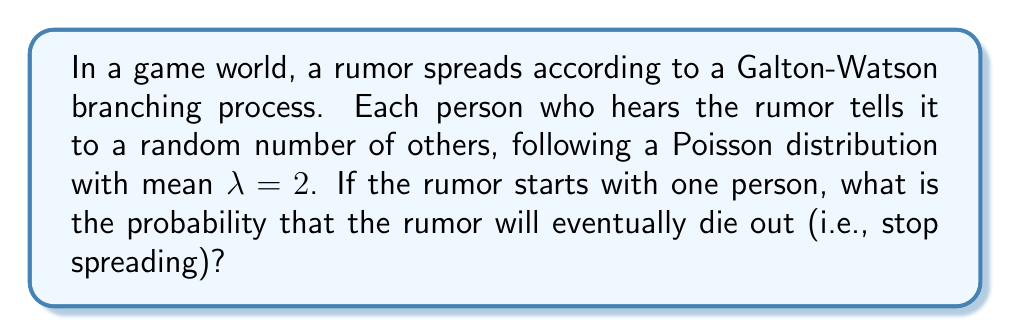Help me with this question. To solve this problem, we'll follow these steps:

1) In a Galton-Watson process, the probability of extinction is the smallest non-negative root of the equation:

   $$s = G(s)$$

   where $G(s)$ is the probability generating function of the offspring distribution.

2) For a Poisson distribution with mean $\lambda$, the probability generating function is:

   $$G(s) = e^{\lambda(s-1)}$$

3) Substituting our $\lambda = 2$, we get:

   $$s = e^{2(s-1)}$$

4) This equation cannot be solved algebraically. We need to use numerical methods.

5) We can see that $s = 1$ is always a solution, but this is not always the smallest positive root.

6) For a branching process, the extinction probability is less than 1 if and only if $\lambda > 1$.

7) Since our $\lambda = 2 > 1$, we know the extinction probability is less than 1.

8) Using numerical methods (e.g., Newton's method), we can find that the smallest positive root is approximately 0.2032.

This solution is relevant to game storytelling as it models how information (or misinformation) might realistically spread through a game world, affecting character interactions and plot development.
Answer: $0.2032$ 